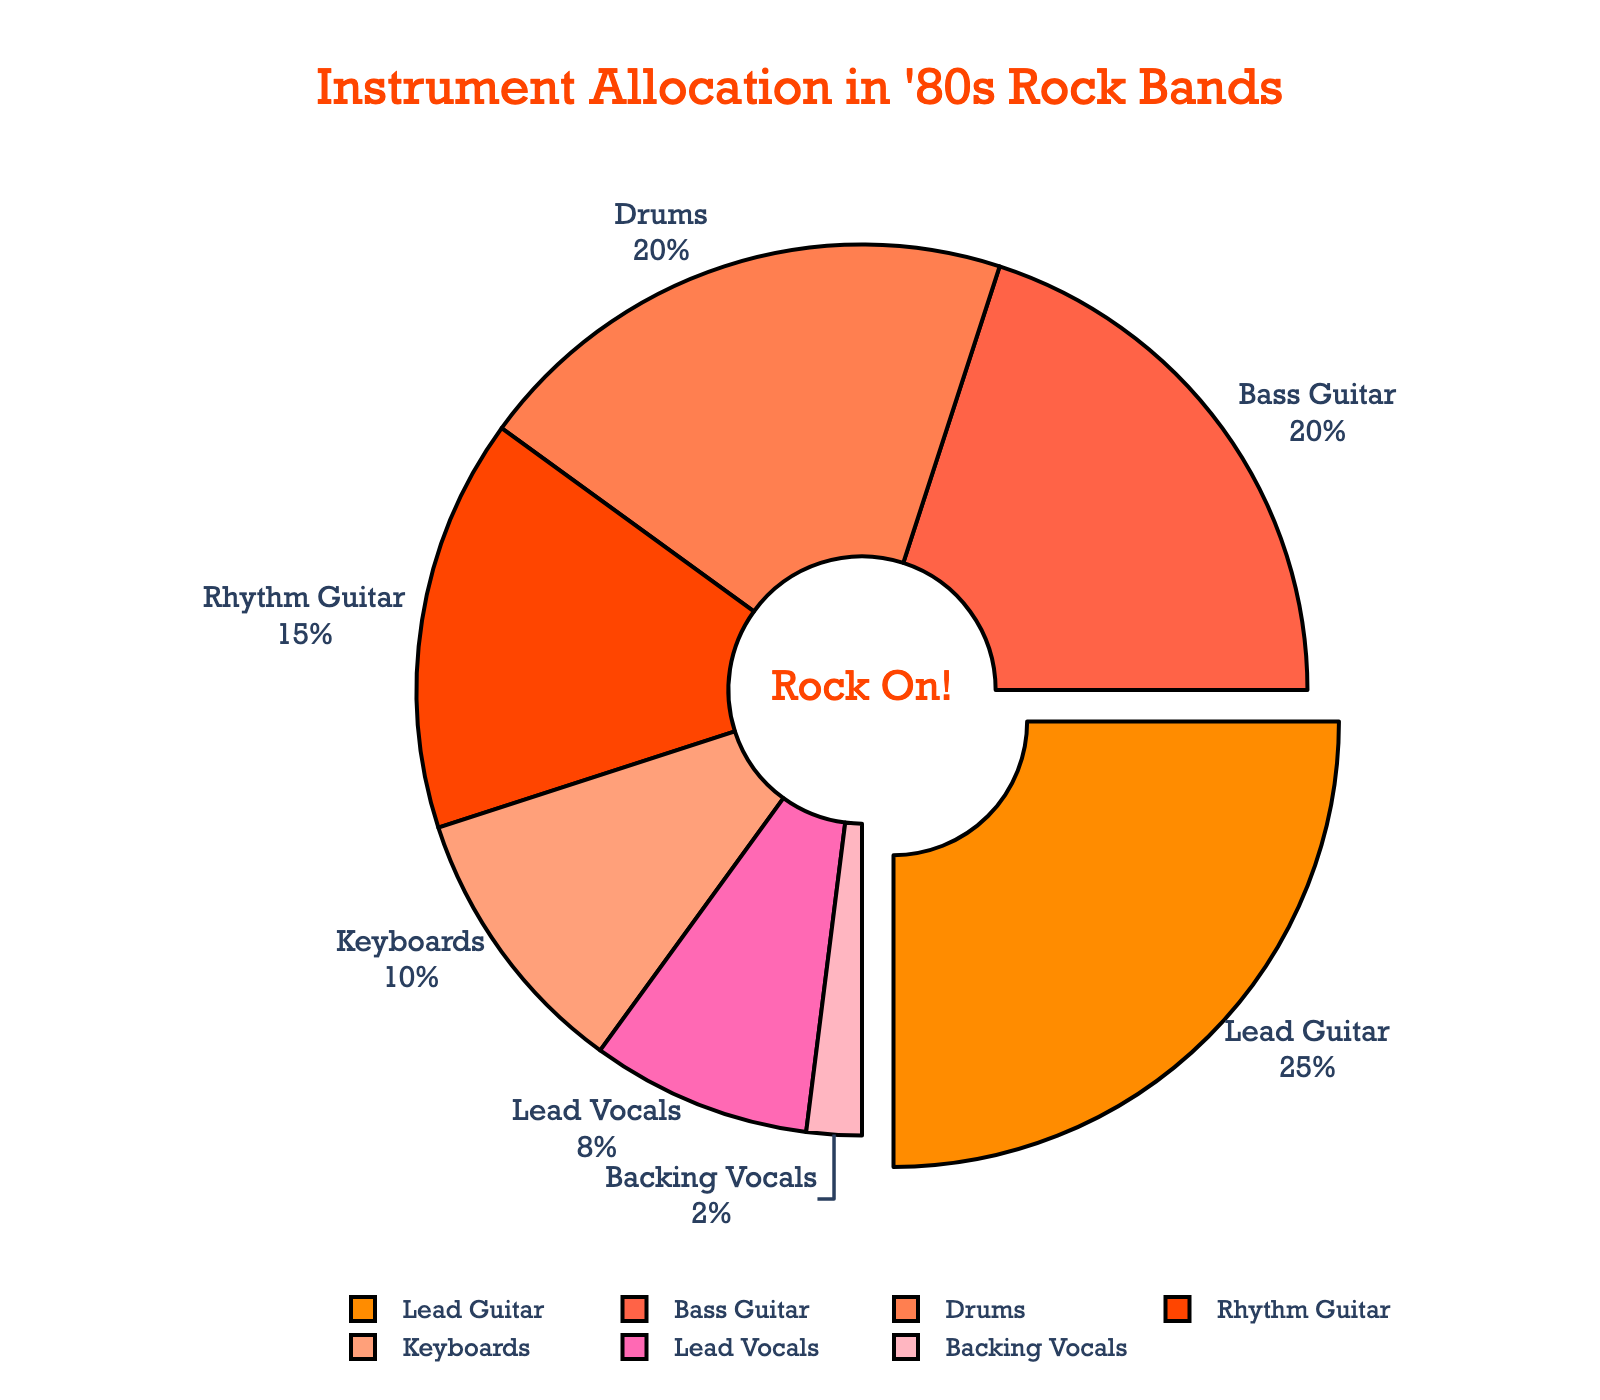What is the most represented instrument in the pie chart? The pie chart's segments show each instrument's percentage. The lead guitar has the largest segment with 25%.
Answer: Lead Guitar Which instrument shares equal percentage values in the pie chart? By examining the percentages, the bass guitar and drums each occupy 20%.
Answer: Bass Guitar and Drums What is the combined percentage of lead and rhythm guitars? Sum the percentages of lead guitar (25%) and rhythm guitar (15%). 25% + 15% = 40%.
Answer: 40% Which instruments have a combined percentage larger than keyboards? Keyboards have 10%. Drums (20%), bass guitar (20%), lead vocals (8%) and rhythm guitar (15%) have individual percentages larger than 10%. Combined percentages of lead vocals and backing vocals (10%) are equal to keyboards'.
Answer: Drums, Bass Guitar, Rhythm Guitar Which instruments occupy the smallest percentages of the chart? The slices for lead vocals (8%) and backing vocals (2%) are the smallest ones.
Answer: Lead Vocals and Backing Vocals Are the percentages of bass guitar and drums higher or lower than lead guitar? Lead guitar occupies 25% while bass guitar and drums each occupy 20%, making them lower than the lead guitar's 25%.
Answer: Lower How much more percentage does the lead guitar have compared to keyboards? Subtract the percentage of keyboards (10%) from the lead guitar's percentage (25%). 25% - 10% = 15%.
Answer: 15% What is the total percentage for vocals (lead and backing)? Summing the percentages for lead vocals (8%) and backing vocals (2%) gives 8% + 2% = 10%.
Answer: 10% What segment's color is used for the representation of rhythm guitar and how can you identify it? Rhythm guitar is represented by a specific shade of orange, and you can identify it by looking for the label "Rhythm Guitar" next to the colored slice.
Answer: Orange Which slice is slightly pulled out from the pie chart and why? The lead guitar slice is slightly pulled out to emphasize it because it has the highest percentage (25%).
Answer: Lead Guitar 